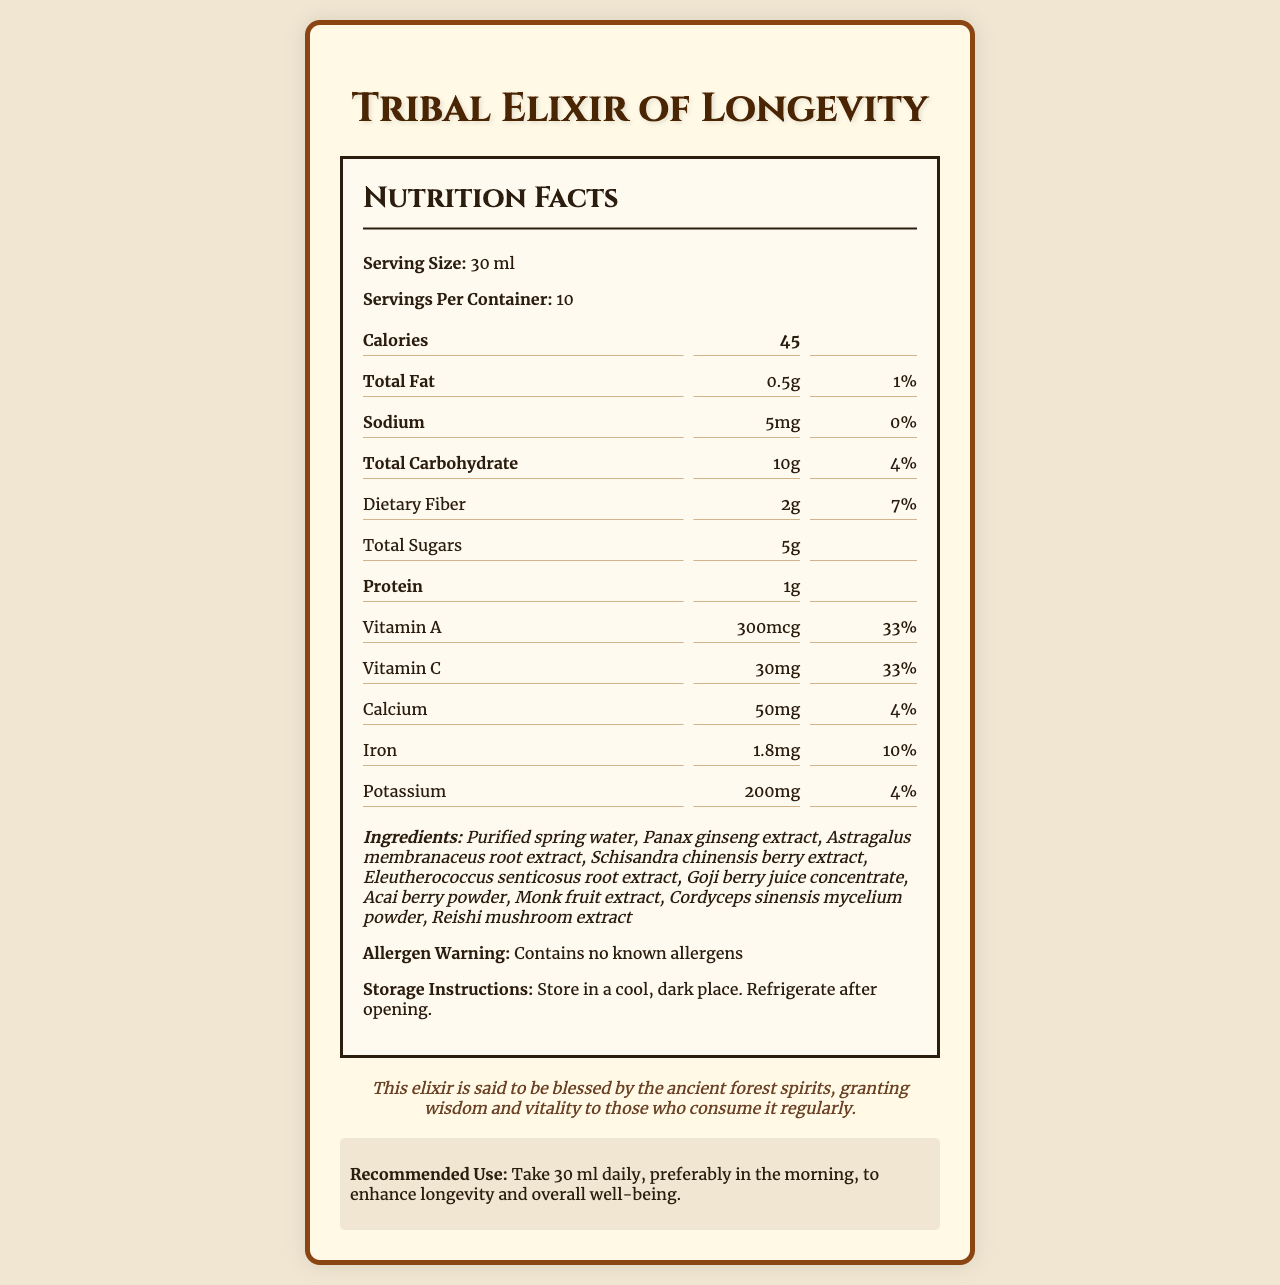what is the serving size? The serving size is mentioned at the beginning of the nutrition facts: "Serving Size: 30 ml."
Answer: 30 ml how many servings are there per container? The document states: "Servings Per Container: 10."
Answer: 10 how much calcium is present per serving? Under the nutrition information, it specifies: "Calcium: 50 mg."
Answer: 50 mg what is the amount of total sugars per serving? The nutrition info shows: "Total Sugars: 5g."
Answer: 5g how much protein is in each serving? The protein content is listed as: "Protein: 1g."
Answer: 1g which vitamin is highest in daily value percentage? A. Vitamin A B. Vitamin C C. Calcium D. Iron Vitamin A and Vitamin C both have a daily value of 33%, which is the highest listed.
Answer: A what are the instructions for storing the elixir? A. Store in a warm, bright place B. Refrigerate immediately C. Store in a cool, dark place and refrigerate after opening D. None of the above The storage instructions are: "Store in a cool, dark place. Refrigerate after opening."
Answer: C is there any dietary fiber in this elixir? The nutrition facts indicate: "Dietary Fiber: 2g."
Answer: Yes summarize the main idea of the document. The document provides comprehensive nutritional information about the elixir, including caloric content, macronutrients, vitamins, and minerals, and lists its ingredients. It also includes storage instructions, an allergen warning, a tribal legend that emphasizes the elixir's vitality-enhancing properties, and recommended usage instructions.
Answer: The document is a nutrition facts label for a secret longevity elixir from a rival tribe, detailing serving size, nutrients, ingredients, storage instructions, and a tribal legend. how many calories are there in two servings of the elixir? Each serving contains 45 calories. Therefore, two servings contain 45 x 2 = 90 calories.
Answer: 90 does the elixir contain any allergens? The document states: "Contains no known allergens."
Answer: No what is the name of the secret compound present at 50 mg per serving in the elixir? The paragraph lists: "astragalosides: 50 mg."
Answer: Astragalosides what are the ancient forest spirits believed to grant to those who consume the elixir regularly? The tribal legend section states: "granting wisdom and vitality to those who consume it regularly."
Answer: Wisdom and vitality what flavor additives are used in the elixir? The document does not list flavor additives explicitly but only specifies the ingredients, some of which may contribute natural flavors.
Answer: Cannot be determined what type of extract is used from Panax ginseng? A. Berry extract B. Root extract C. Leaf extract D. Whole plant extract The ingredients list: "Panax ginseng extract", typically root extract but not specified further here. The closest match unrelated to berries is root extract.
Answer: B 